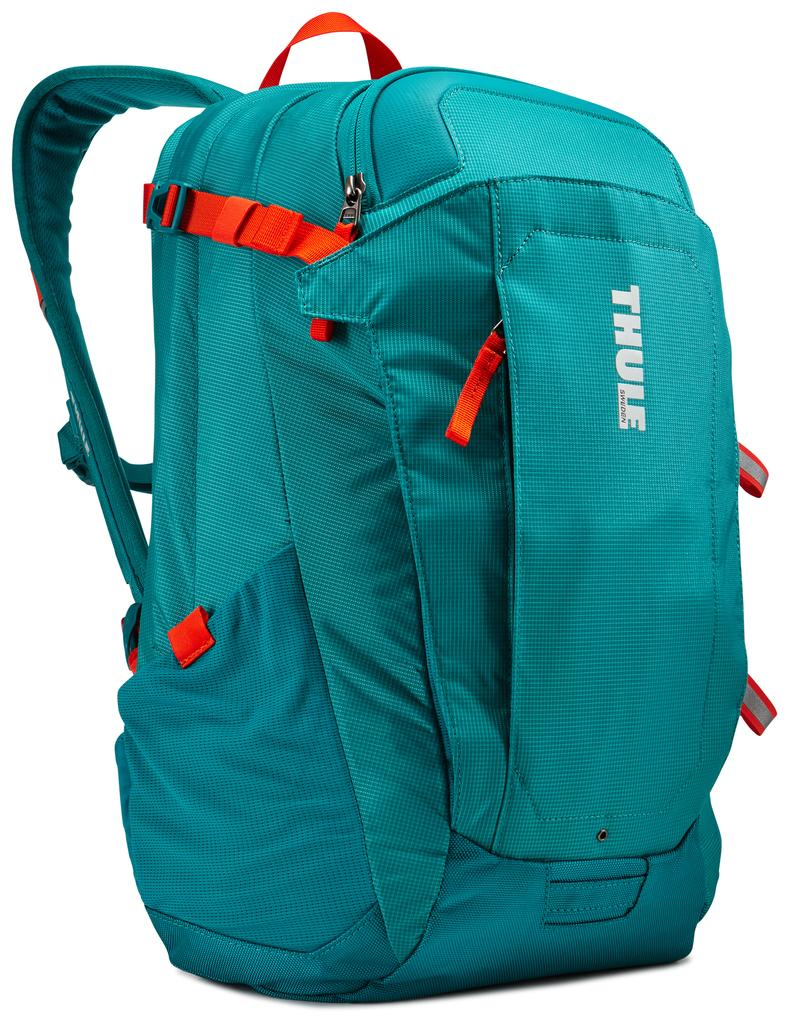Provide a one-sentence caption for the provided image. An aqua blue backpack made by Thule Sweden. 